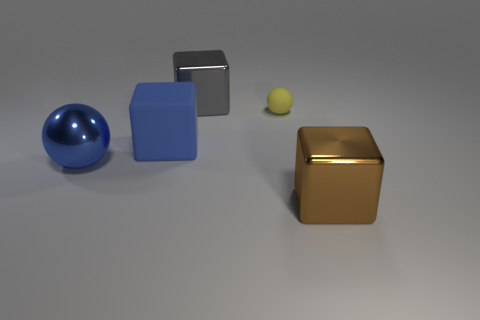How does the light interact with the objects in the image, and what can you tell about the materials they might be made of based on that? The objects exhibit different qualities of reflectiveness, suggesting a variety of materials. The blue ball has a smooth, reflective surface, likely indicative of a polished metal or plastic. The cube to the left has a matte finish, perhaps denoting a softer, less reflective material like painted wood. The golden cube, with its mirror-like reflection, seems metallic and highly polished. Finally, the small yellow ball's muted sheen could imply a rubbery or slightly rough texture. 